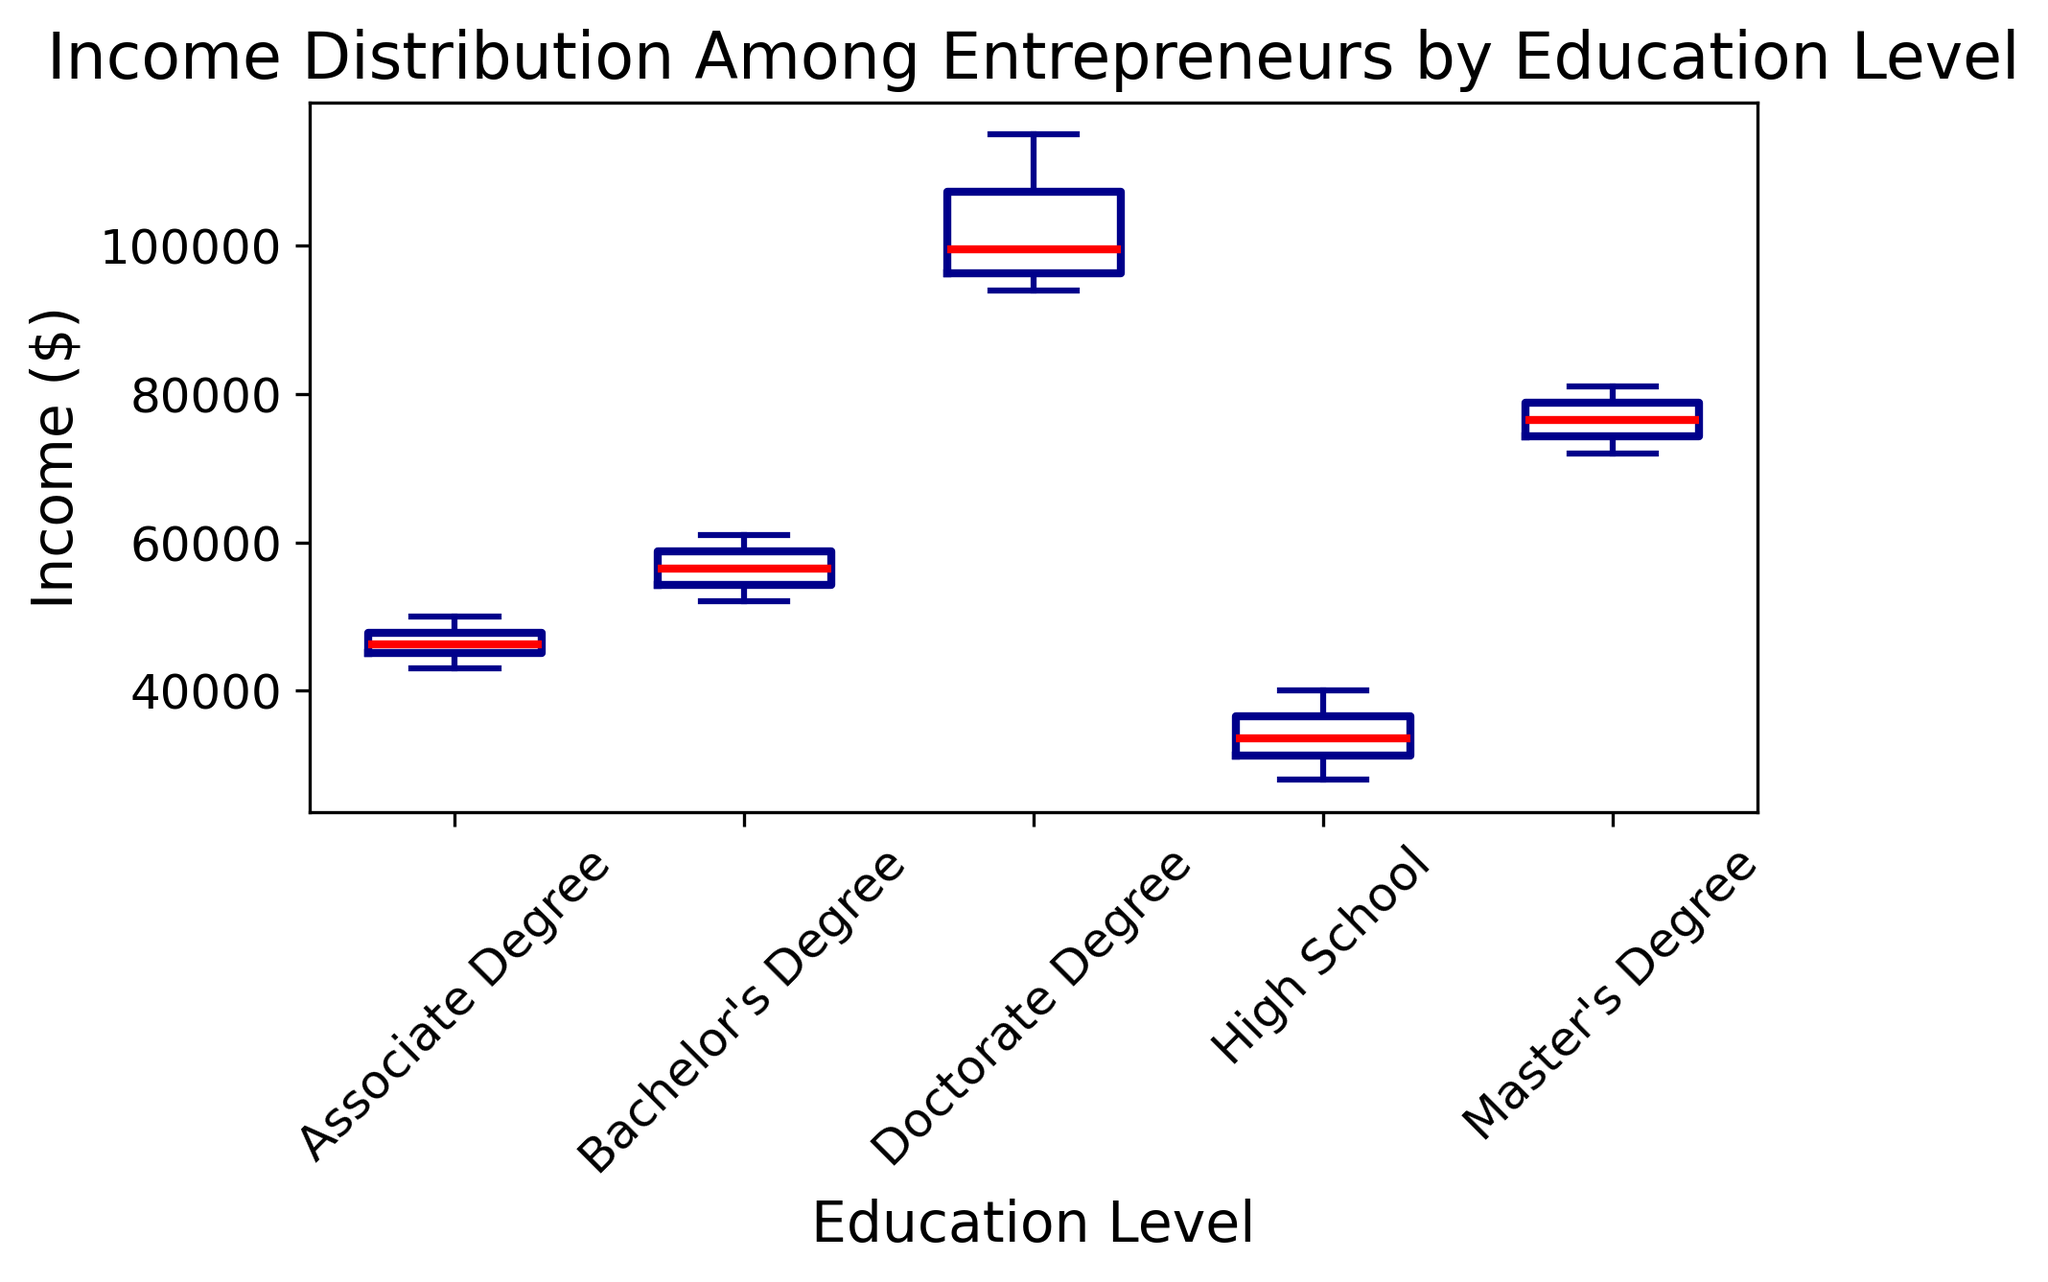What's the median income for entrepreneurs with a Bachelor's Degree? To find the median income for entrepreneurs with a Bachelor's Degree, locate the middle value of the data points presented in the figure. The median is represented by the red line inside the box.
Answer: 57000 Which education level has the highest median income? To determine which education level has the highest median income, check the red lines inside each box plot and compare their vertical positions. The highest red line indicates the highest median income.
Answer: Doctorate Degree What is the income range (difference between highest and lowest values) for entrepreneurs with an Associate Degree? The income range is calculated by subtracting the lowest value (bottom whisker) from the highest value (top whisker) for the Associate Degree group. Use the visual markers (whiskers) to identify these values.
Answer: 7000 Is the median income for entrepreneurs with a Master's Degree lower than for those with a Doctorate Degree? Compare the positions of the red lines (medians) in the boxes representing Master's Degree and Doctorate Degree groups. The red line for the Doctorate Degree should be higher if its median is greater.
Answer: Yes Which education level shows the widest variability in income? The widest box plot, including its whiskers and any outliers, represents the education level with the greatest variability in income. Observe the height from the bottom whisker to the top whisker and any outliers.
Answer: Doctorate Degree How does the median income for High School graduates compare to that of Associate Degree holders? Examine the red lines inside the boxes for High School and Associate Degree groups. Compare their vertical positions to see which is higher or if they are at the same level.
Answer: Higher for Associate Degree holders Are there any outliers in the Master's Degree income group? Look for any individual data points marked outside the whiskers of the box plot for the Master's Degree group. These points indicate outliers.
Answer: No What is the interquartile range (IQR) for entrepreneurs with a Bachelor's Degree? The IQR is the difference between the third quartile (top edge of the box) and the first quartile (bottom edge of the box). Identify these edges from the box plot for the Bachelor's Degree group and subtract the lower value from the higher value.
Answer: 10000 Which group has incomes predominantly above 100,000 dollars? Identify the group whose box plot primarily lies above the 100,000-dollar mark on the y-axis. The group with the majority of its box above this value has incomes predominantly above 100,000 dollars.
Answer: Doctorate Degree How does the spread of incomes for High School graduates compare to that of Master's Degree holders? Compare the lengths of the boxes and whiskers of the High School and Master's Degree groups. Longer boxes and whiskers indicate a greater spread in incomes.
Answer: Wider for Master's Degree holders 